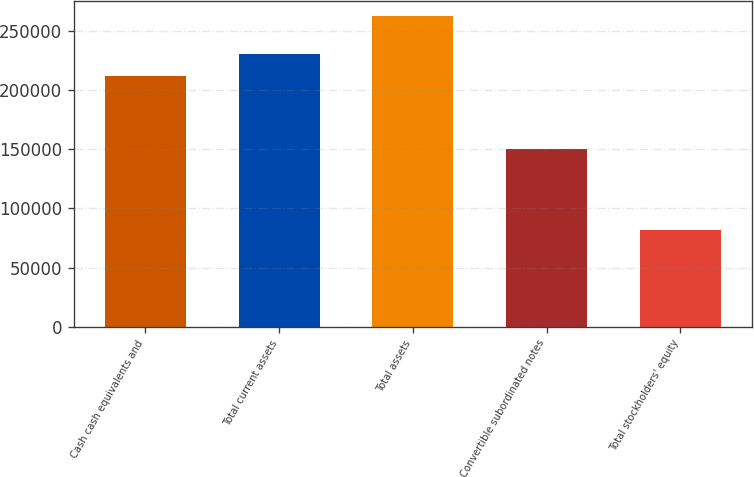<chart> <loc_0><loc_0><loc_500><loc_500><bar_chart><fcel>Cash cash equivalents and<fcel>Total current assets<fcel>Total assets<fcel>Convertible subordinated notes<fcel>Total stockholders' equity<nl><fcel>212456<fcel>230538<fcel>262711<fcel>150000<fcel>81890<nl></chart> 